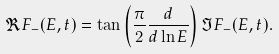Convert formula to latex. <formula><loc_0><loc_0><loc_500><loc_500>\Re F _ { - } ( E , t ) = \tan \left ( \frac { \pi } { 2 } \frac { d } { d \ln { E } } \right ) \Im F _ { - } ( E , t ) .</formula> 